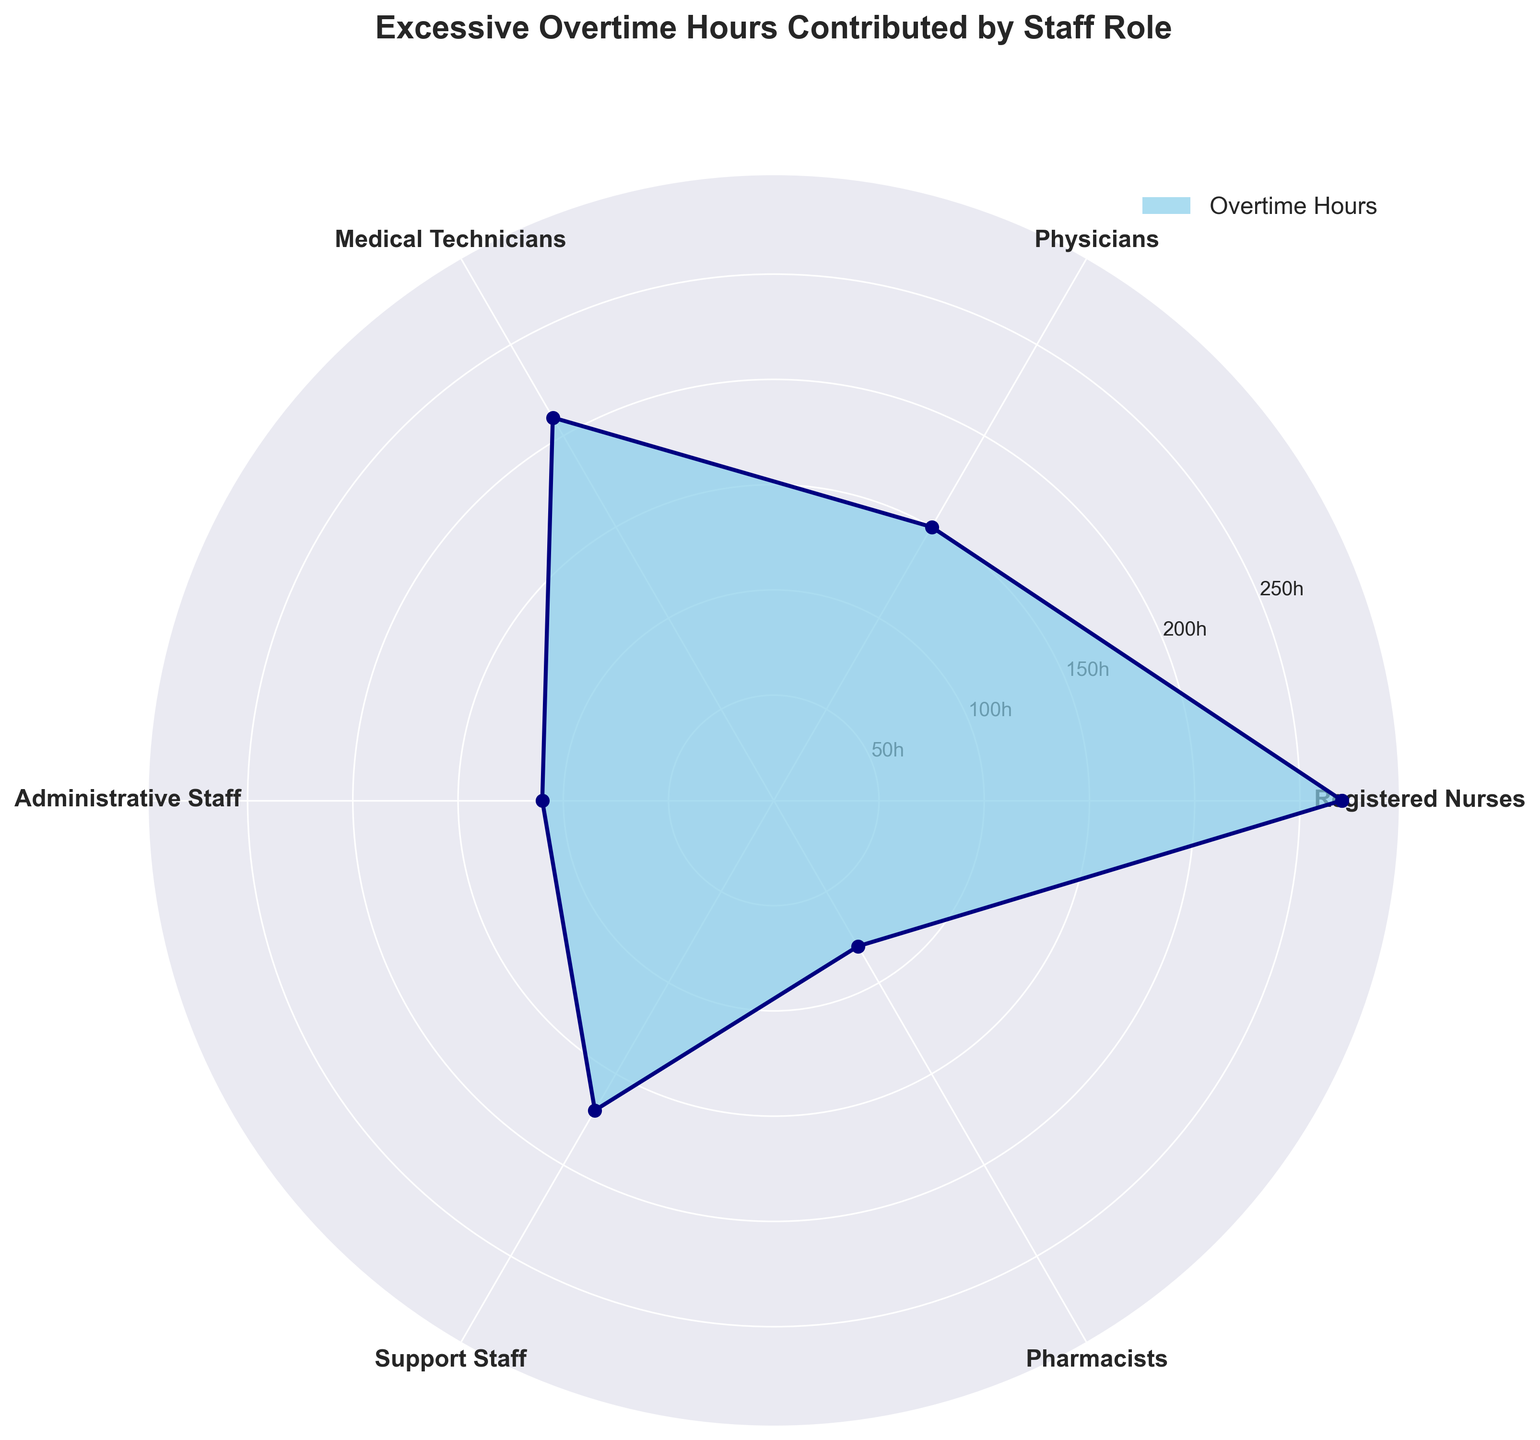what is the title of the figure? The title of the figure is located prominently at the top of the chart and describes the content. By looking at the topmost part of the chart, we can read the title.
Answer: Excessive Overtime Hours Contributed by Staff Role how many different staff roles are displayed? By counting the distinct labels around the polar area chart, we can determine the number of different staff roles. There are six different labels around the chart.
Answer: six which staff role contributes the most to excessive overtime hours? By identifying the area that extends furthest from the center, we can determine which staff role has the highest value for excessive overtime hours. The largest area corresponds to Registered Nurses.
Answer: registered nurses what is the excessive overtime hours contributed by physicians? By locating the position for Physicians on the polar area chart and noting the value at this point, we can determine the excessive overtime hours contributed.
Answer: 150 how much more overtime do registered nurses contribute compared to administrative staff? To find this, identify the values for registered nurses and administrative staff, subtract the latter from the former: 270 (Registered Nurses) - 110 (Administrative Staff) = 160.
Answer: 160 which staff roles contribute less than 150 hours of excessive overtime? By checking each label and its corresponding value around the chart to see if it's less than 150, the role that fits this criteria is Pharmacists.
Answer: pharmacists rank the staff roles from highest to lowest in terms of excessive overtime hours contributed By comparing the values for each staff role around the chart and ordering them from highest to lowest: Registered Nurses (270), Medical Technicians (210), Support Staff (170), Physicians (150), Administrative Staff (110), Pharmacists (80).
Answer: registered nurses, medical technicians, support staff, physicians, administrative staff, pharmacists what's the total amount of excessive overtime hours contributed by support staff and medical technicians combined? Add the contributions of Support Staff and Medical Technicians: 170 (Support Staff) + 210 (Medical Technicians) = 380.
Answer: 380 how does the overtime contribution of support staff compare to that of physicians? Compare the values for Support Staff and Physicians from the chart. Support Staff contributes 170 hours, while Physicians contribute 150 hours. Thus, Support Staff contribute more.
Answer: support staff contribute more what color is used to fill the area representing overtime contributions? By looking at the filled area of the chart, we can determine the color used. The area is filled with sky blue.
Answer: sky blue 